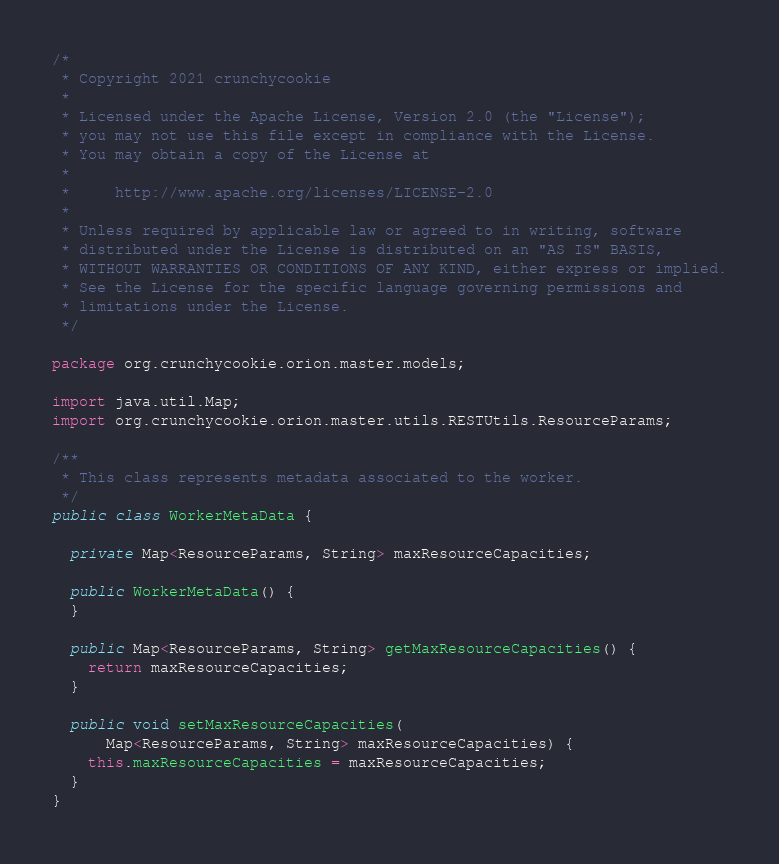Convert code to text. <code><loc_0><loc_0><loc_500><loc_500><_Java_>/*
 * Copyright 2021 crunchycookie
 *
 * Licensed under the Apache License, Version 2.0 (the "License");
 * you may not use this file except in compliance with the License.
 * You may obtain a copy of the License at
 *
 *     http://www.apache.org/licenses/LICENSE-2.0
 *
 * Unless required by applicable law or agreed to in writing, software
 * distributed under the License is distributed on an "AS IS" BASIS,
 * WITHOUT WARRANTIES OR CONDITIONS OF ANY KIND, either express or implied.
 * See the License for the specific language governing permissions and
 * limitations under the License.
 */

package org.crunchycookie.orion.master.models;

import java.util.Map;
import org.crunchycookie.orion.master.utils.RESTUtils.ResourceParams;

/**
 * This class represents metadata associated to the worker.
 */
public class WorkerMetaData {

  private Map<ResourceParams, String> maxResourceCapacities;

  public WorkerMetaData() {
  }

  public Map<ResourceParams, String> getMaxResourceCapacities() {
    return maxResourceCapacities;
  }

  public void setMaxResourceCapacities(
      Map<ResourceParams, String> maxResourceCapacities) {
    this.maxResourceCapacities = maxResourceCapacities;
  }
}
</code> 